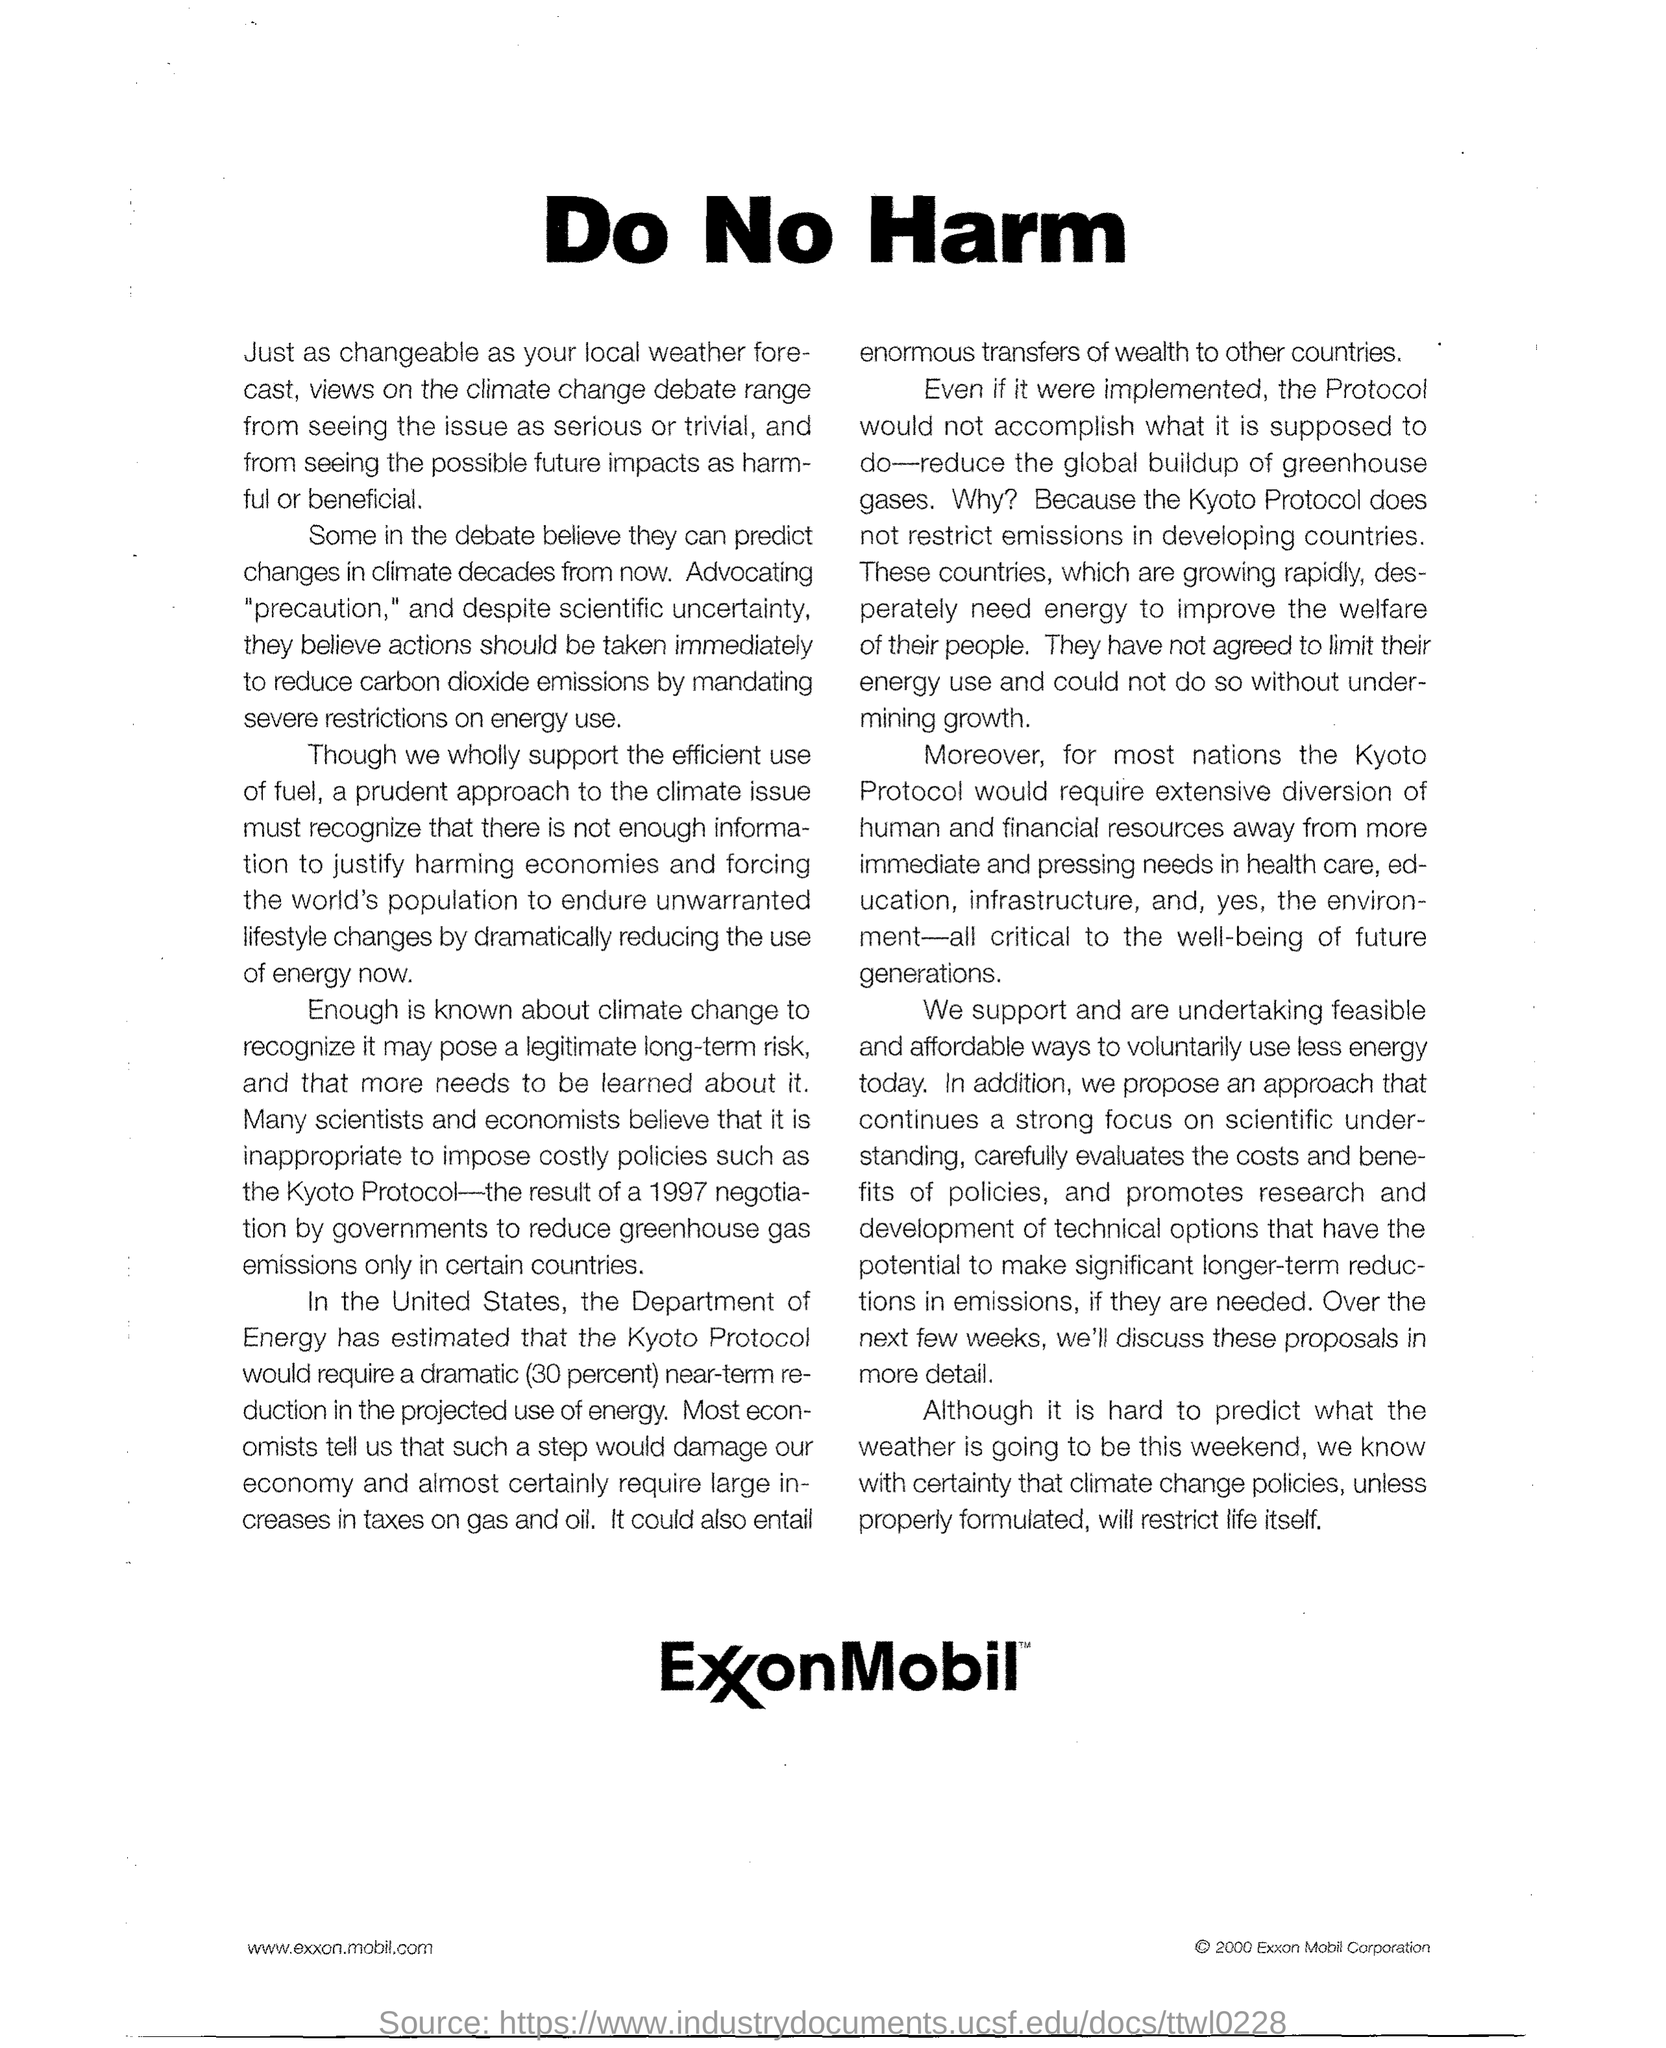What is the title?
Your answer should be very brief. Do No Harm. What protocol was imposed by government in certain countries?
Provide a succinct answer. Kyoto protocol. 